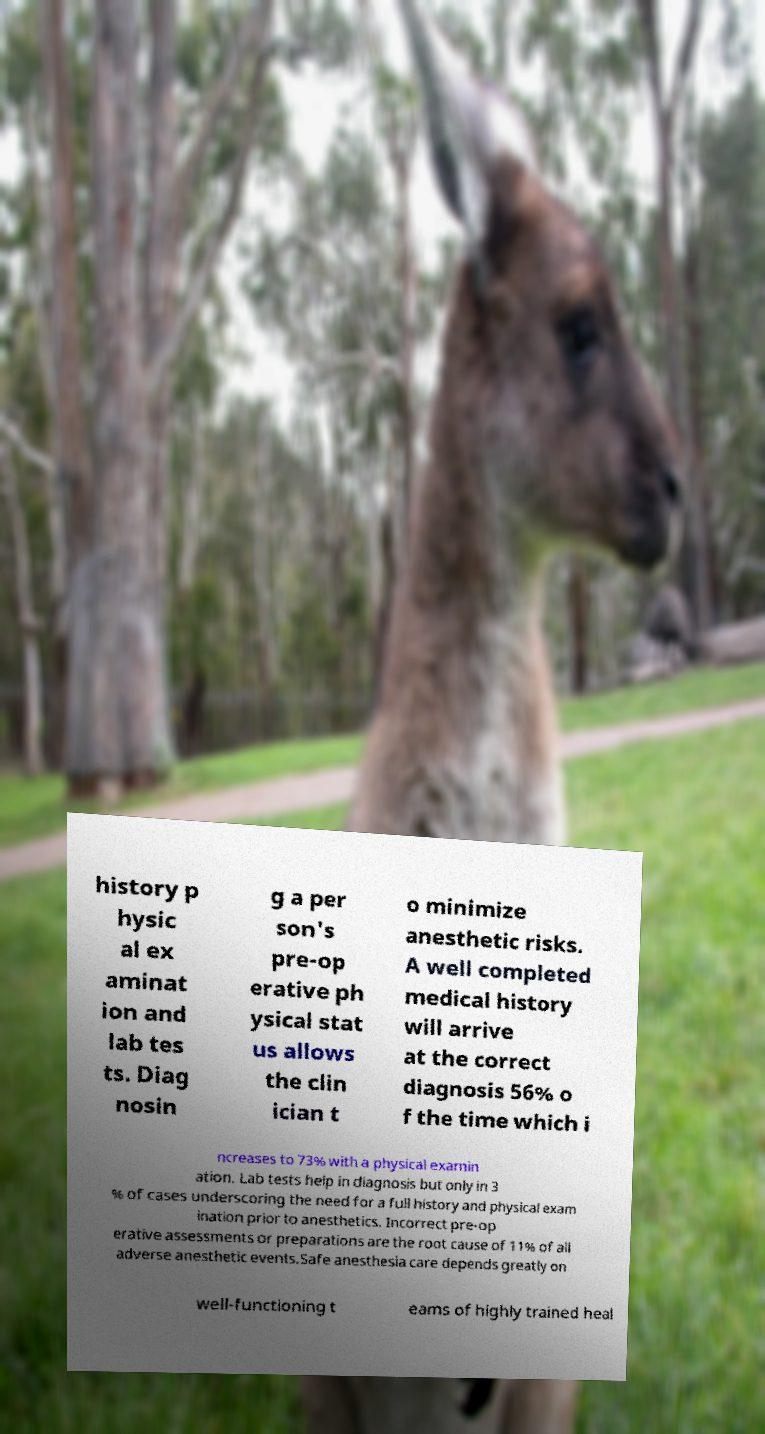Can you accurately transcribe the text from the provided image for me? history p hysic al ex aminat ion and lab tes ts. Diag nosin g a per son's pre-op erative ph ysical stat us allows the clin ician t o minimize anesthetic risks. A well completed medical history will arrive at the correct diagnosis 56% o f the time which i ncreases to 73% with a physical examin ation. Lab tests help in diagnosis but only in 3 % of cases underscoring the need for a full history and physical exam ination prior to anesthetics. Incorrect pre-op erative assessments or preparations are the root cause of 11% of all adverse anesthetic events.Safe anesthesia care depends greatly on well-functioning t eams of highly trained heal 